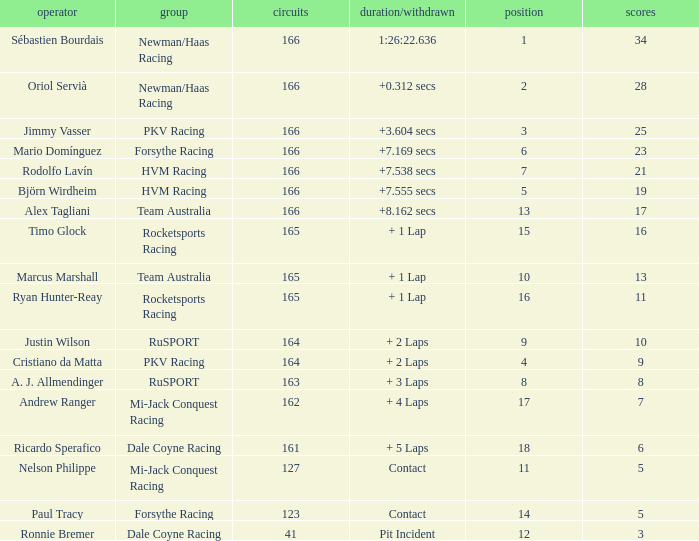What is the average points that the driver Ryan Hunter-Reay has? 11.0. 